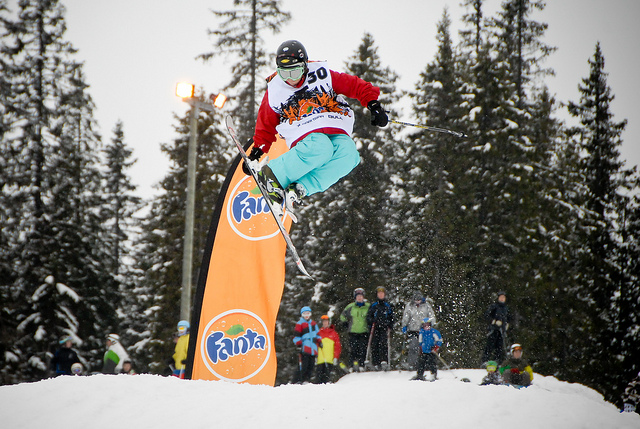Please transcribe the text information in this image. FANTA Fan 30 